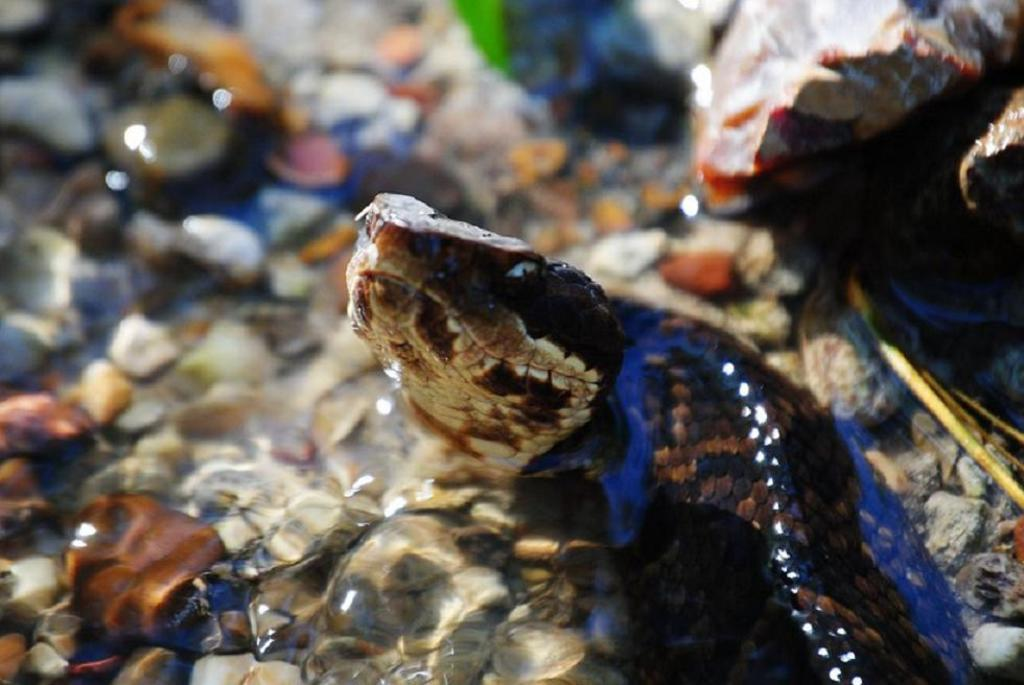What type of animal is present in the image? There is a snake in the image. Can you describe the background of the image? The background of the image is blurry. What type of pipe can be seen in the image? There is no pipe present in the image. Is there a dog visible in the image? No, there is no dog present in the image. What type of house is shown in the image? There is no house present in the image. 